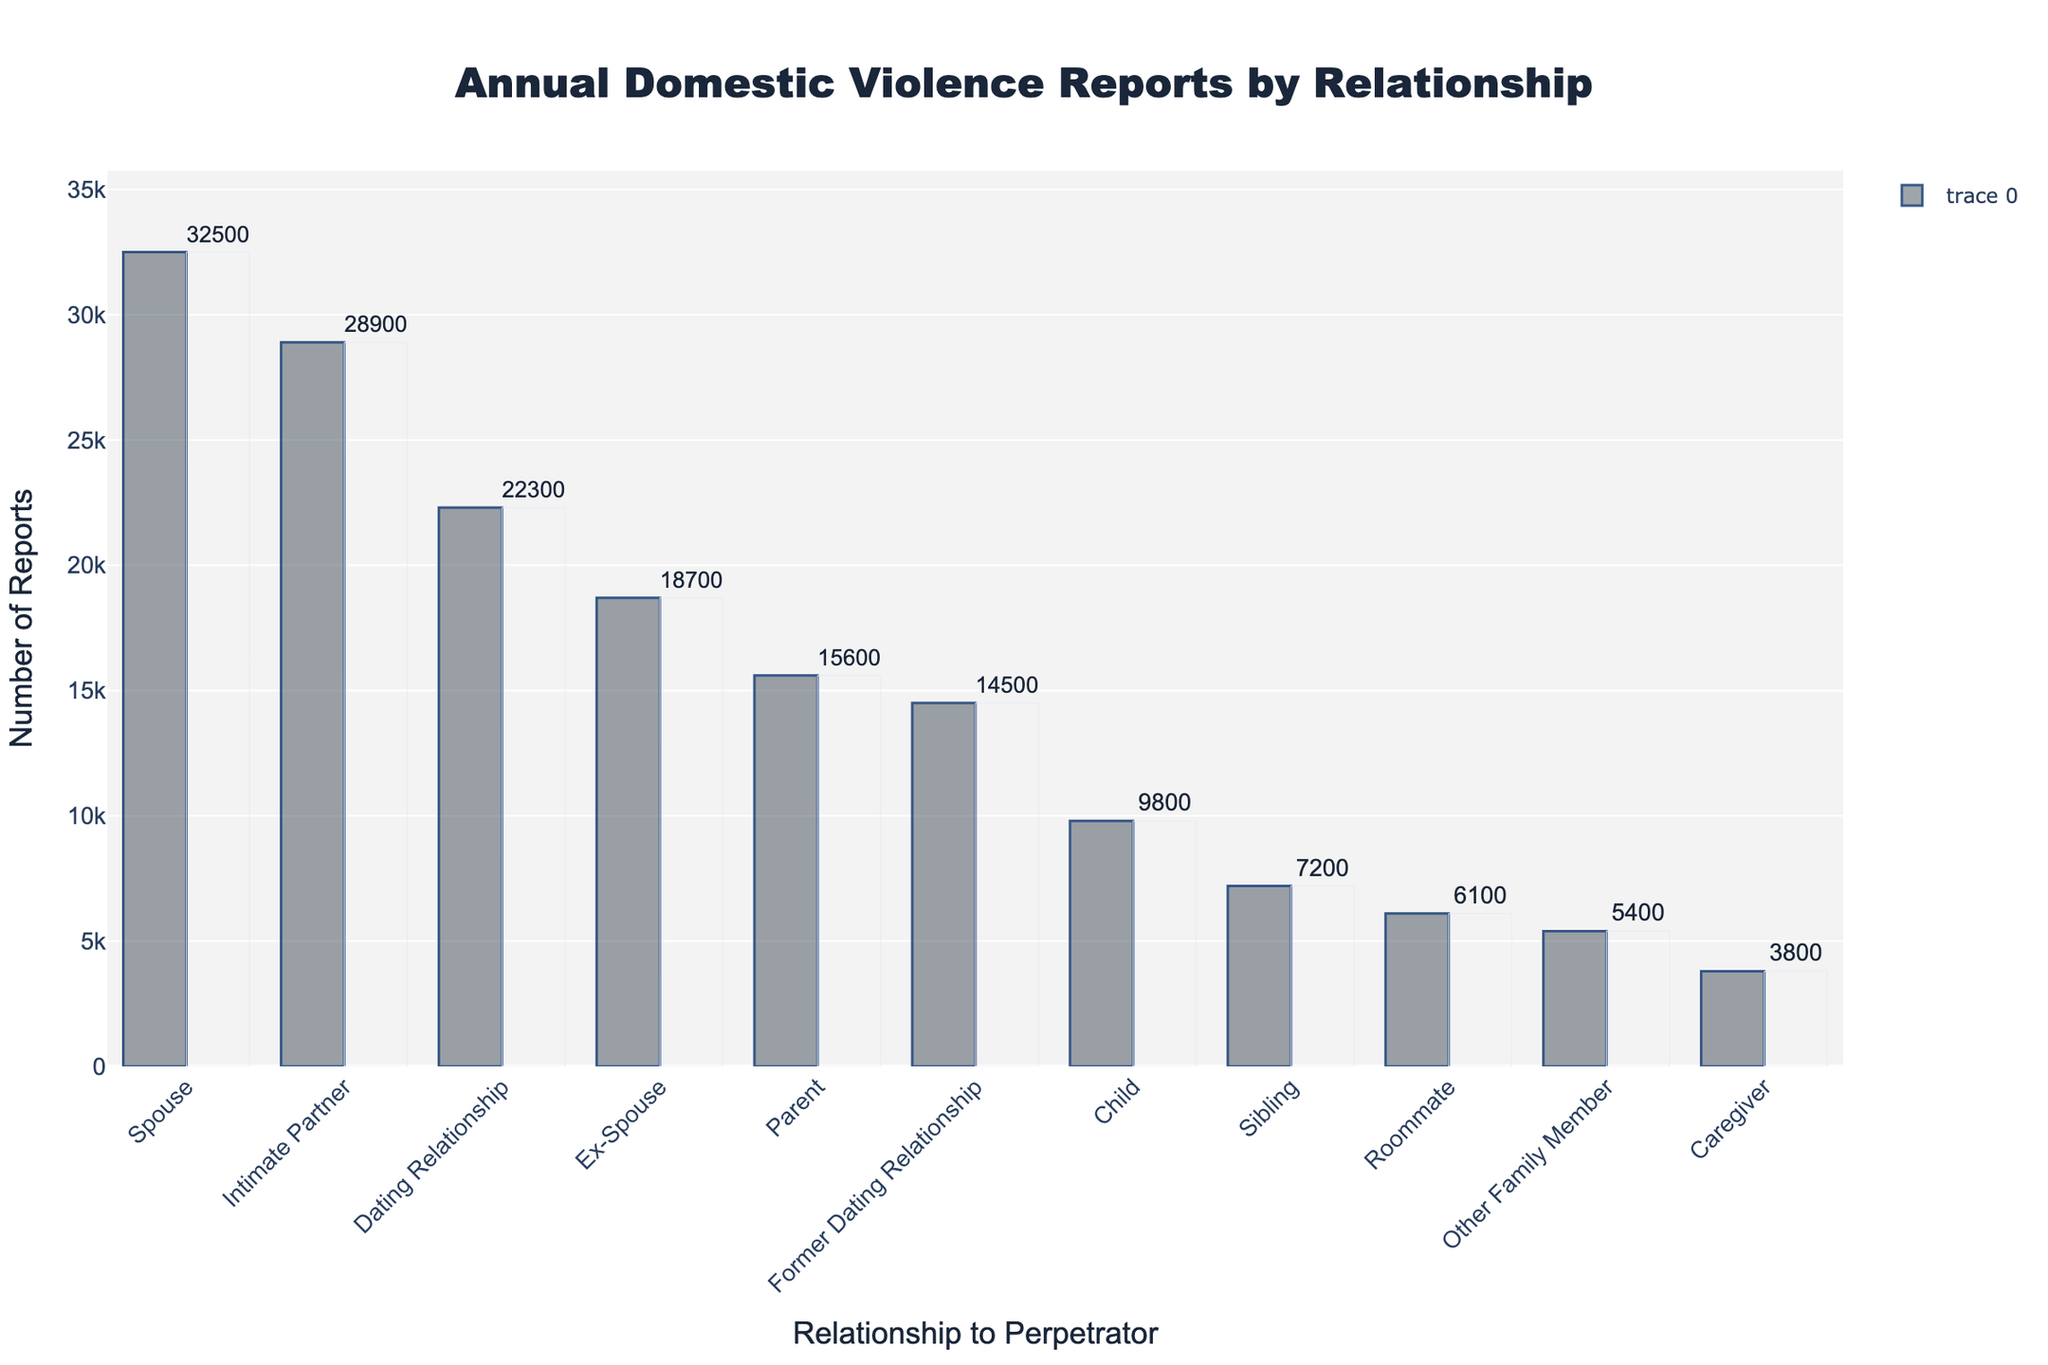What relationship has the highest number of domestic violence reports? By looking at the figure, the relationship with the tallest bar represents the highest number of reports. Spouse has the tallest bar, indicating it has the highest number of reports.
Answer: Spouse Which relationship category is reported more frequently, Ex-Spouse or Sibling? To compare these two categories, observe the heights of the bars for Ex-Spouse and Sibling. The Ex-Spouse bar is significantly taller than the Sibling bar.
Answer: Ex-Spouse How many more reports are there for Intimate Partner compared to Parent? First, find the number of reports for both categories: Intimate Partner (28,900) and Parent (15,600). Subtract the number of reports for Parent from Intimate Partner (28,900 - 15,600).
Answer: 13,300 What's the total number of reports for the categories involving a child (Child, Caregiver)? Sum the numbers of reports for Child (9,800) and Caregiver (3,800). The addition operation is 9,800 + 3,800.
Answer: 13,600 Which relationship category has fewer reports, Roommate or Other Family Member? Compare the heights of the bars for Roommate and Other Family Member. The bar for Other Family Member is shorter than that for Roommate.
Answer: Other Family Member What is the average number of reports for the top three reported categories? Identify the top three categories by the height of their bars: Spouse (32,500), Intimate Partner (28,900), and Dating Relationship (22,300). Sum these numbers (32,500 + 28,900 + 22,300) and divide by 3. The calculation is (32,500 + 28,900 + 22,300) / 3.
Answer: 27,900 How many total reports were recorded for the top five categories? Identify the top five categories: Spouse, Intimate Partner, Dating Relationship, Ex-Spouse, and Former Dating Relationship. Sum their reports (32,500 + 28,900 + 22,300 + 18,700 + 14,500). The calculation is 32,500 + 28,900 + 22,300 + 18,700 + 14,500.
Answer: 116,900 What percent of the total reports are made up by the Sibling and Roommate categories combined? First, sum the reports for all categories to get the total number of reports (32,500 + 18,700 + 28,900 + 15,600 + 9,800 + 7,200 + 5,400 + 3,800 + 6,100 + 22,300 + 14,500) which equals 164,800. Then find the sum of Sibling and Roommate reports (7,200 + 6,100) which equals 13,300. Calculate the percent as (13,300 / 164,800) * 100.
Answer: ~8.1% Which categories combined have a higher number of reports: Caregiver and Roommate or Parent and Sibling? Sum the reports for Caregiver and Roommate (3,800 + 6,100 = 9,900) and for Parent and Sibling (15,600 + 7,200 = 22,800). Compare the sums.
Answer: Parent and Sibling 